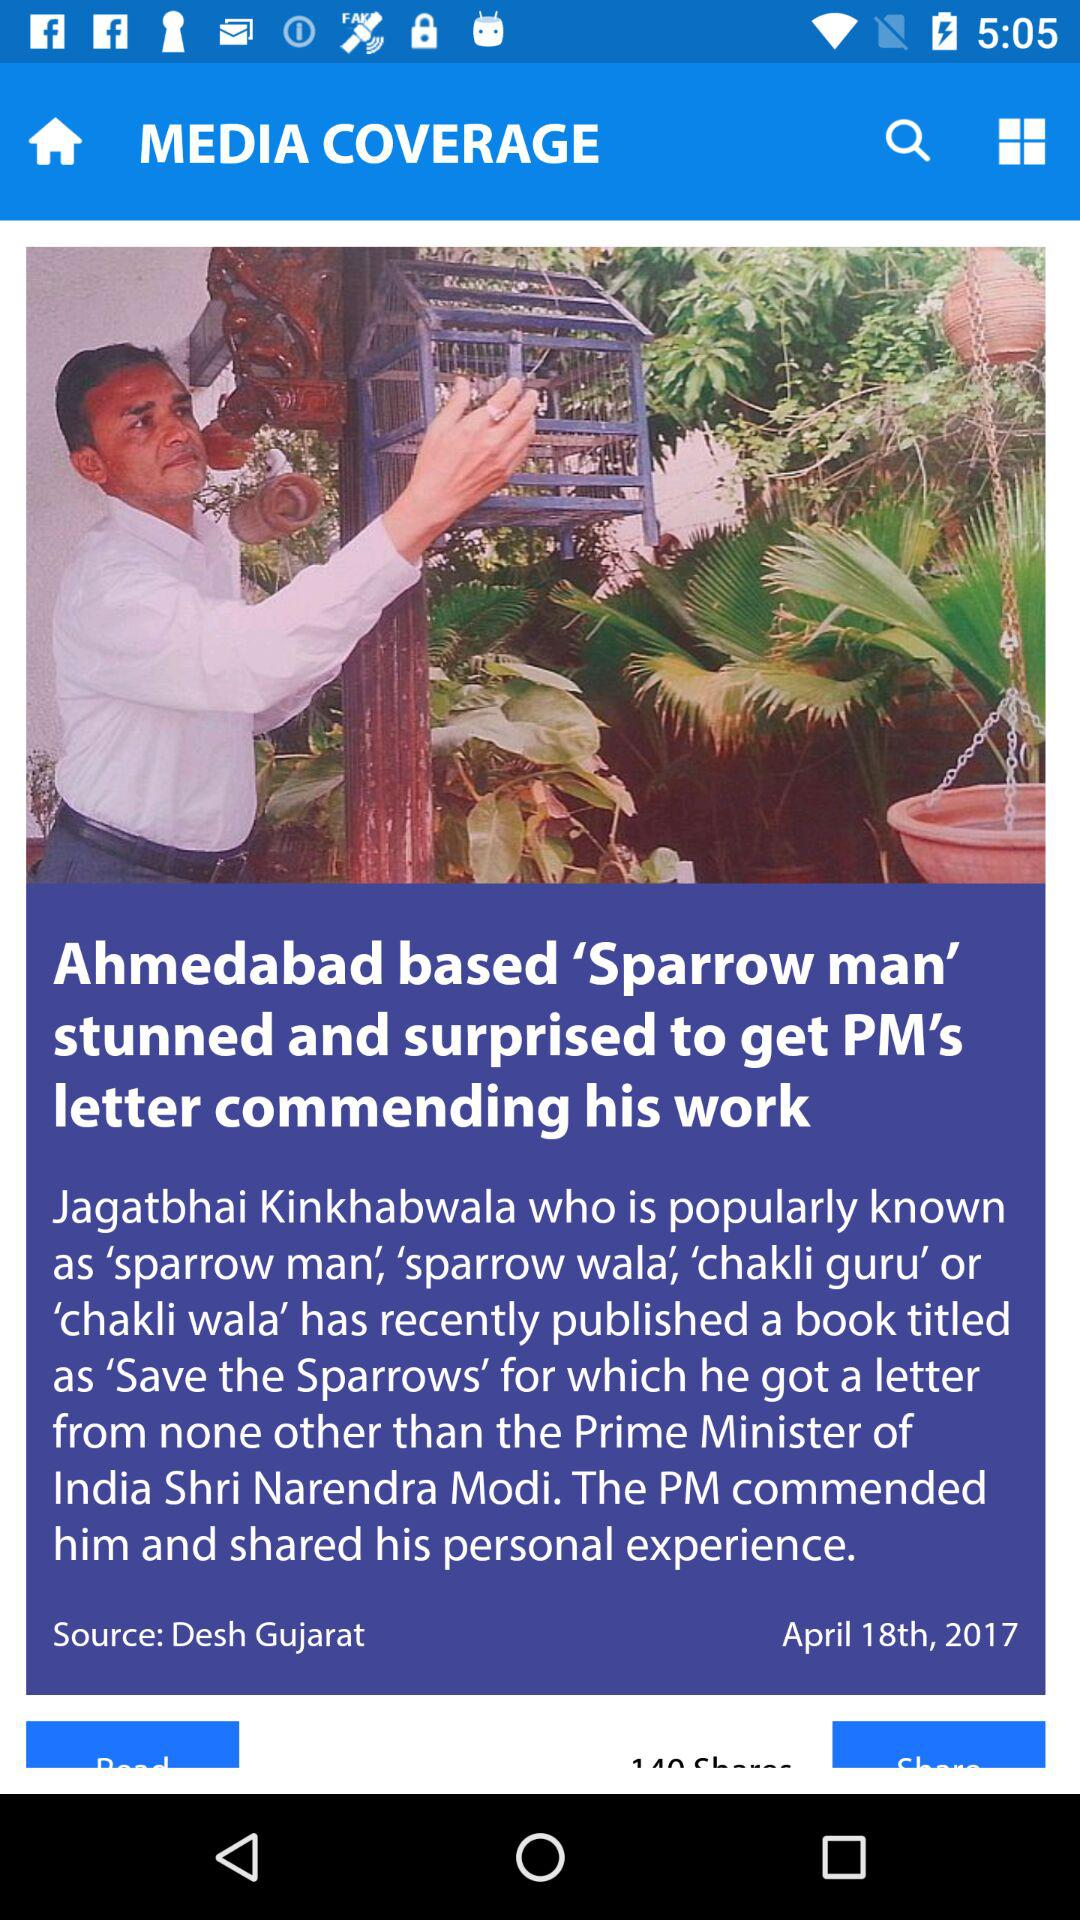What book was published by Jagatbhai Kinkhabwala? Jagatbhai Kinkhabwala published "Save the Sparrows". 